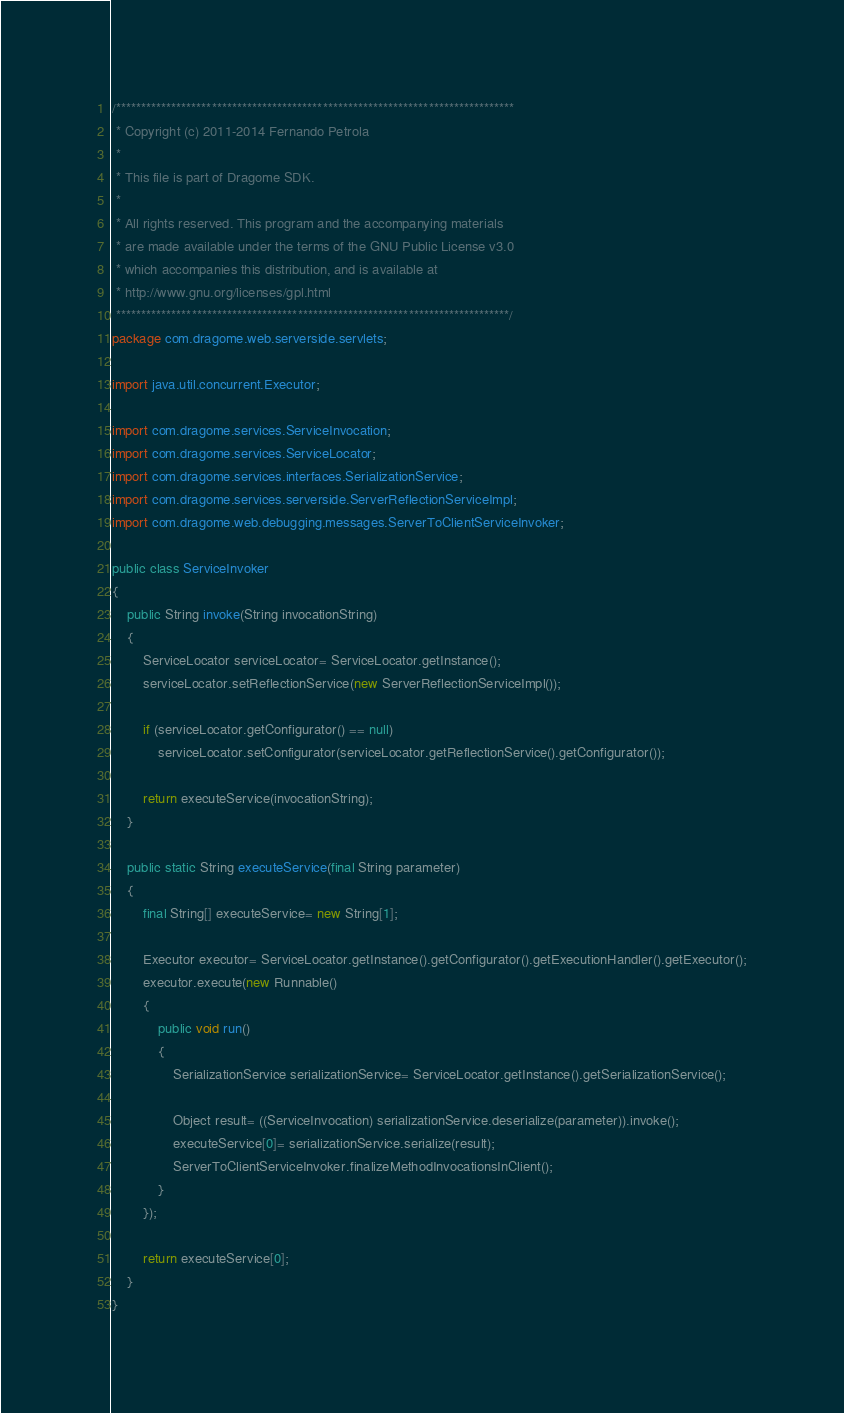Convert code to text. <code><loc_0><loc_0><loc_500><loc_500><_Java_>/*******************************************************************************
 * Copyright (c) 2011-2014 Fernando Petrola
 * 
 * This file is part of Dragome SDK.
 * 
 * All rights reserved. This program and the accompanying materials
 * are made available under the terms of the GNU Public License v3.0
 * which accompanies this distribution, and is available at
 * http://www.gnu.org/licenses/gpl.html
 ******************************************************************************/
package com.dragome.web.serverside.servlets;

import java.util.concurrent.Executor;

import com.dragome.services.ServiceInvocation;
import com.dragome.services.ServiceLocator;
import com.dragome.services.interfaces.SerializationService;
import com.dragome.services.serverside.ServerReflectionServiceImpl;
import com.dragome.web.debugging.messages.ServerToClientServiceInvoker;

public class ServiceInvoker
{
	public String invoke(String invocationString)
	{
		ServiceLocator serviceLocator= ServiceLocator.getInstance();
		serviceLocator.setReflectionService(new ServerReflectionServiceImpl());
		
		if (serviceLocator.getConfigurator() == null)
			serviceLocator.setConfigurator(serviceLocator.getReflectionService().getConfigurator());
		
		return executeService(invocationString);
	}

	public static String executeService(final String parameter)
	{
		final String[] executeService= new String[1];

		Executor executor= ServiceLocator.getInstance().getConfigurator().getExecutionHandler().getExecutor();
		executor.execute(new Runnable()
		{
			public void run()
			{
				SerializationService serializationService= ServiceLocator.getInstance().getSerializationService();

				Object result= ((ServiceInvocation) serializationService.deserialize(parameter)).invoke();
				executeService[0]= serializationService.serialize(result);
				ServerToClientServiceInvoker.finalizeMethodInvocationsInClient();
			}
		});

		return executeService[0];
	}
}
</code> 